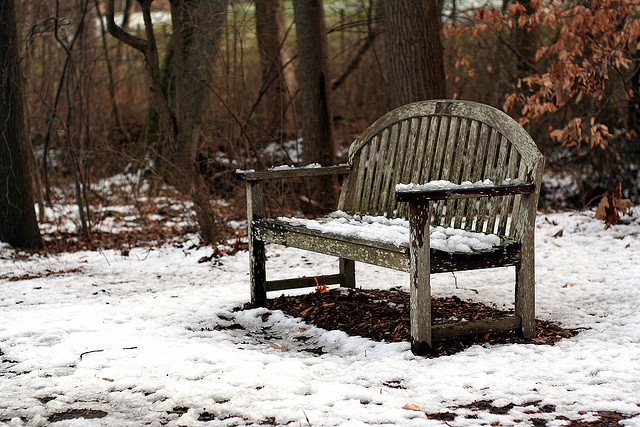Describe the objects in this image and their specific colors. I can see a bench in black, gray, and lightgray tones in this image. 